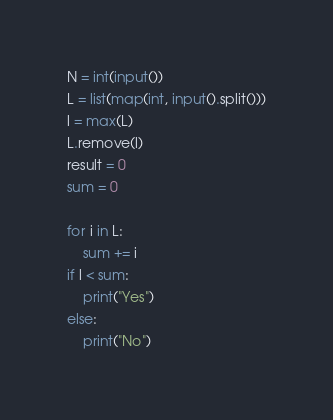Convert code to text. <code><loc_0><loc_0><loc_500><loc_500><_Python_>N = int(input())
L = list(map(int, input().split()))
l = max(L)
L.remove(l)
result = 0
sum = 0

for i in L:
    sum += i
if l < sum:
    print("Yes")
else:
    print("No")
</code> 